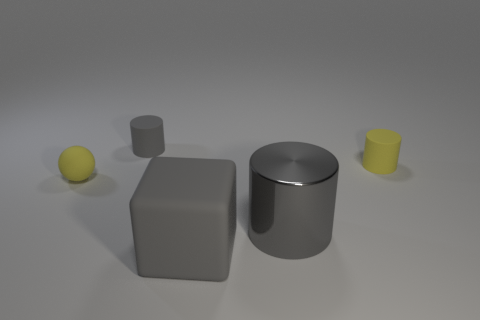How big is the rubber block?
Provide a short and direct response. Large. Are there fewer yellow matte objects on the right side of the large shiny thing than things in front of the yellow cylinder?
Offer a very short reply. Yes. There is a yellow rubber thing that is the same shape as the tiny gray thing; what size is it?
Ensure brevity in your answer.  Small. What number of things are either things that are to the right of the large cube or tiny matte cylinders that are behind the small yellow cylinder?
Provide a short and direct response. 3. Does the rubber block have the same size as the yellow cylinder?
Make the answer very short. No. Is the number of tiny red metallic spheres greater than the number of tiny rubber objects?
Provide a succinct answer. No. What number of other things are there of the same color as the big metallic object?
Your response must be concise. 2. What number of things are yellow rubber blocks or large gray cylinders?
Your response must be concise. 1. Is the shape of the small yellow matte object right of the matte sphere the same as  the metal thing?
Provide a short and direct response. Yes. What is the color of the tiny matte cylinder that is on the left side of the big object that is on the right side of the big gray matte thing?
Your answer should be compact. Gray. 